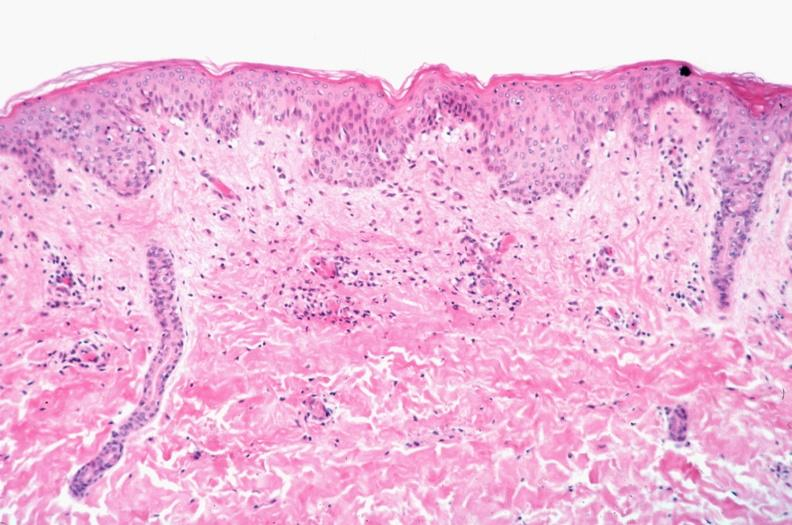s hypersegmented neutrophil spotted fever, vasculitis?
Answer the question using a single word or phrase. No 